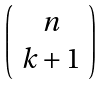Convert formula to latex. <formula><loc_0><loc_0><loc_500><loc_500>\left ( \begin{array} { c } n \\ k + 1 \end{array} \right )</formula> 